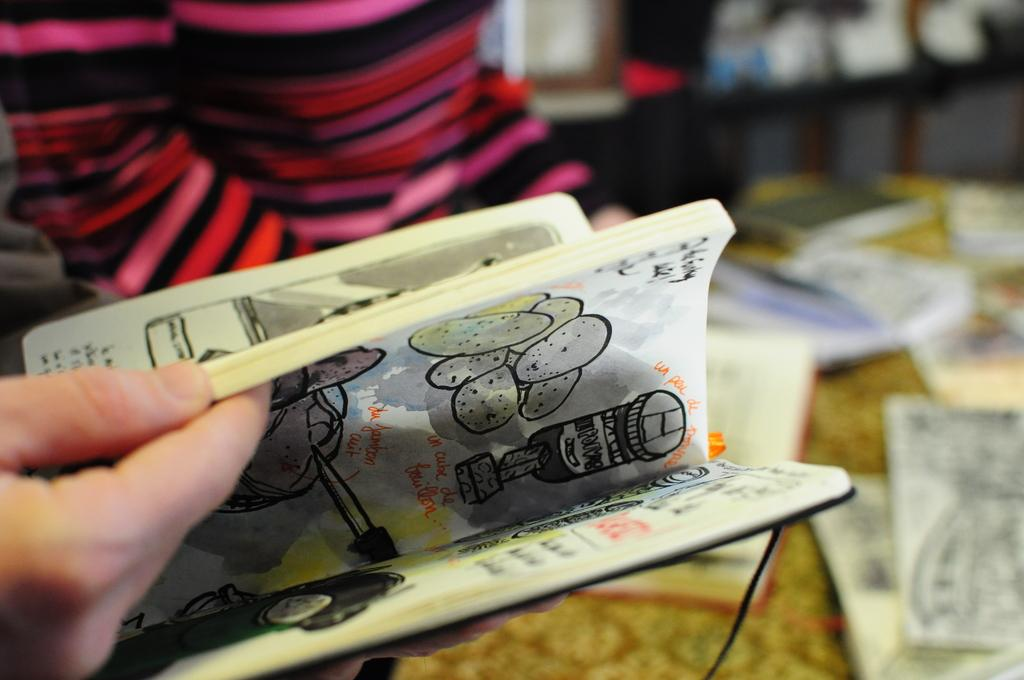What is the main subject of the image? There is a person in the image. What is the person holding in the image? The person is holding a book. Can you describe the background of the image? The background of the image is blurred. What type of meat can be seen hanging from the person's tail in the image? There is no meat or tail present in the image; it features a person holding a book with a blurred background. 